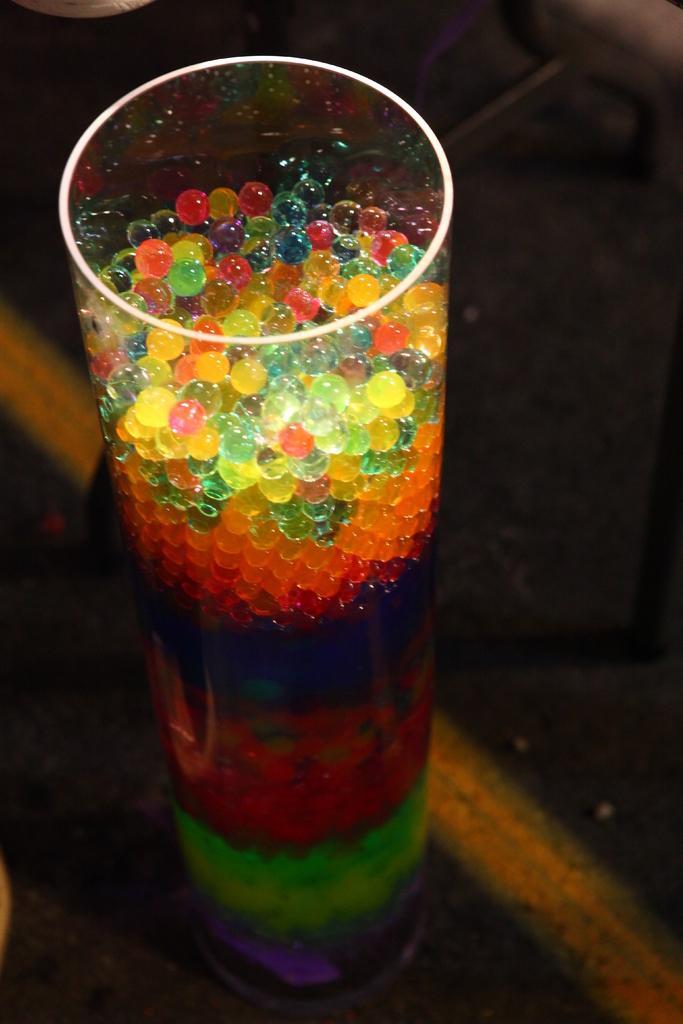Could you give a brief overview of what you see in this image? In this image there is a glass on the ground, there are objects in the glass, there is an object truncated towards the top of the image. 